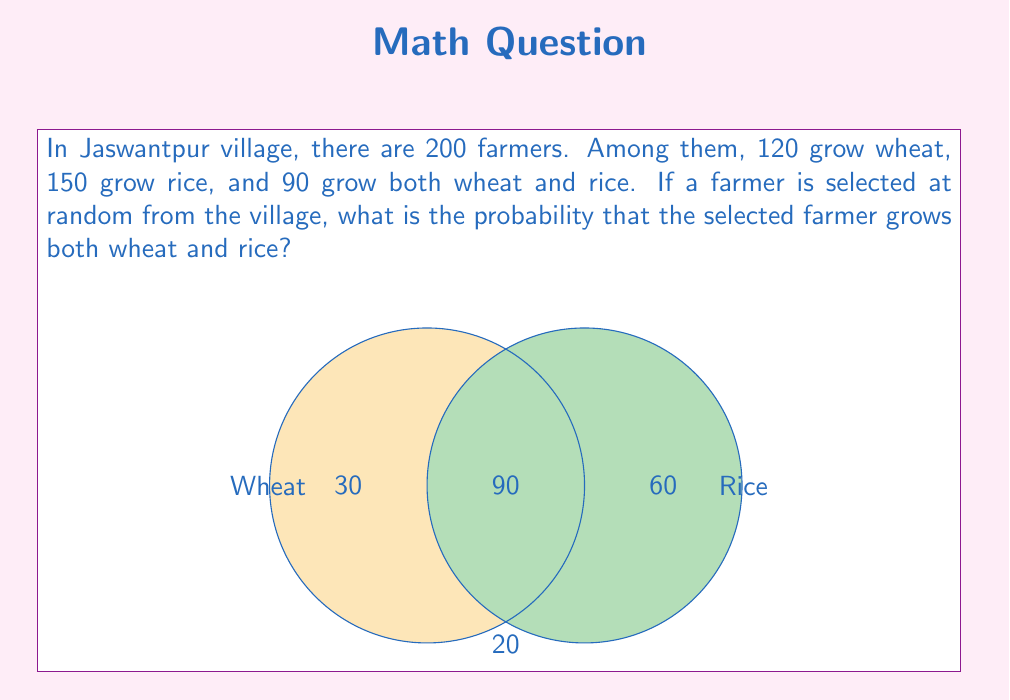Show me your answer to this math problem. Let's approach this step-by-step:

1) First, let's identify the important information:
   - Total number of farmers = 200
   - Farmers growing wheat = 120
   - Farmers growing rice = 150
   - Farmers growing both wheat and rice = 90

2) The probability of an event is calculated by:

   $$ P(\text{event}) = \frac{\text{number of favorable outcomes}}{\text{total number of possible outcomes}} $$

3) In this case:
   - The favorable outcome is selecting a farmer who grows both wheat and rice
   - The total number of possible outcomes is the total number of farmers

4) We know directly from the given information that:
   - Number of farmers growing both wheat and rice = 90
   - Total number of farmers = 200

5) Therefore, the probability is:

   $$ P(\text{both wheat and rice}) = \frac{90}{200} = \frac{9}{20} = 0.45 $$

6) We can verify this using the Venn diagram in the question:
   - Farmers growing only wheat: 30
   - Farmers growing only rice: 60
   - Farmers growing both: 90
   - Farmers growing neither: 20
   Indeed, 30 + 60 + 90 + 20 = 200 (total farmers)
Answer: $\frac{9}{20}$ or $0.45$ or $45\%$ 